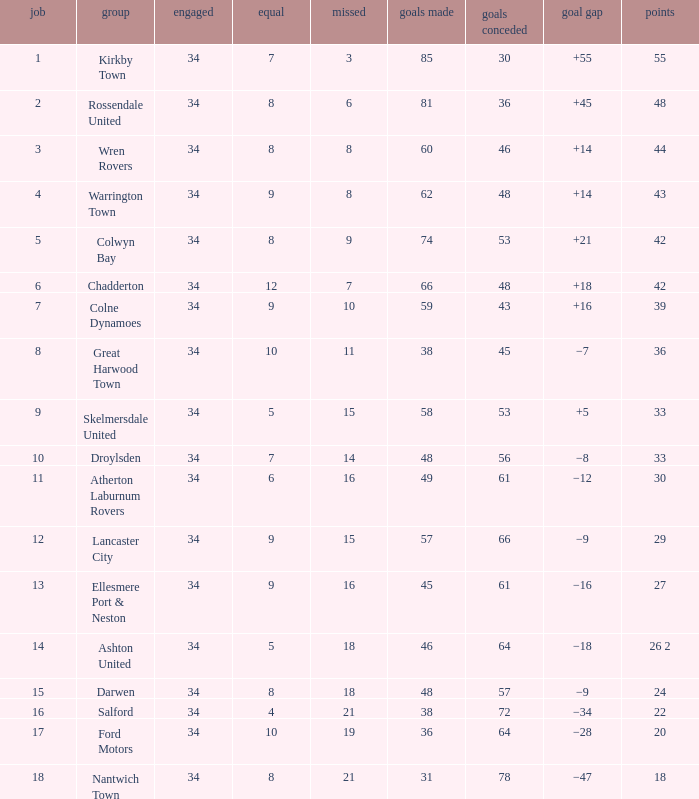What is the smallest number of goals against when 8 games were lost, and the goals for are 60? 46.0. 